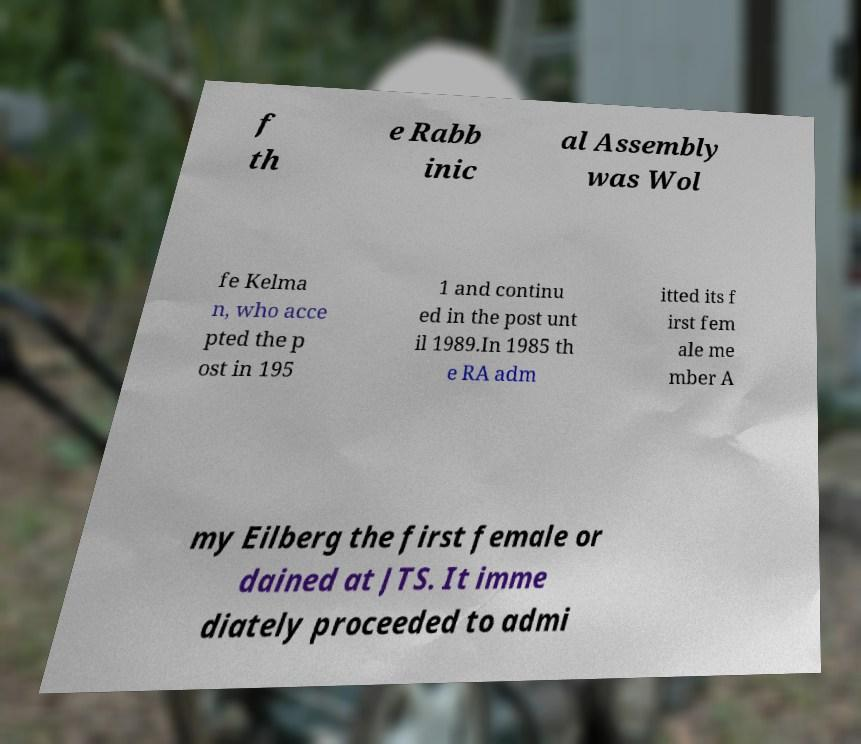Could you assist in decoding the text presented in this image and type it out clearly? f th e Rabb inic al Assembly was Wol fe Kelma n, who acce pted the p ost in 195 1 and continu ed in the post unt il 1989.In 1985 th e RA adm itted its f irst fem ale me mber A my Eilberg the first female or dained at JTS. It imme diately proceeded to admi 